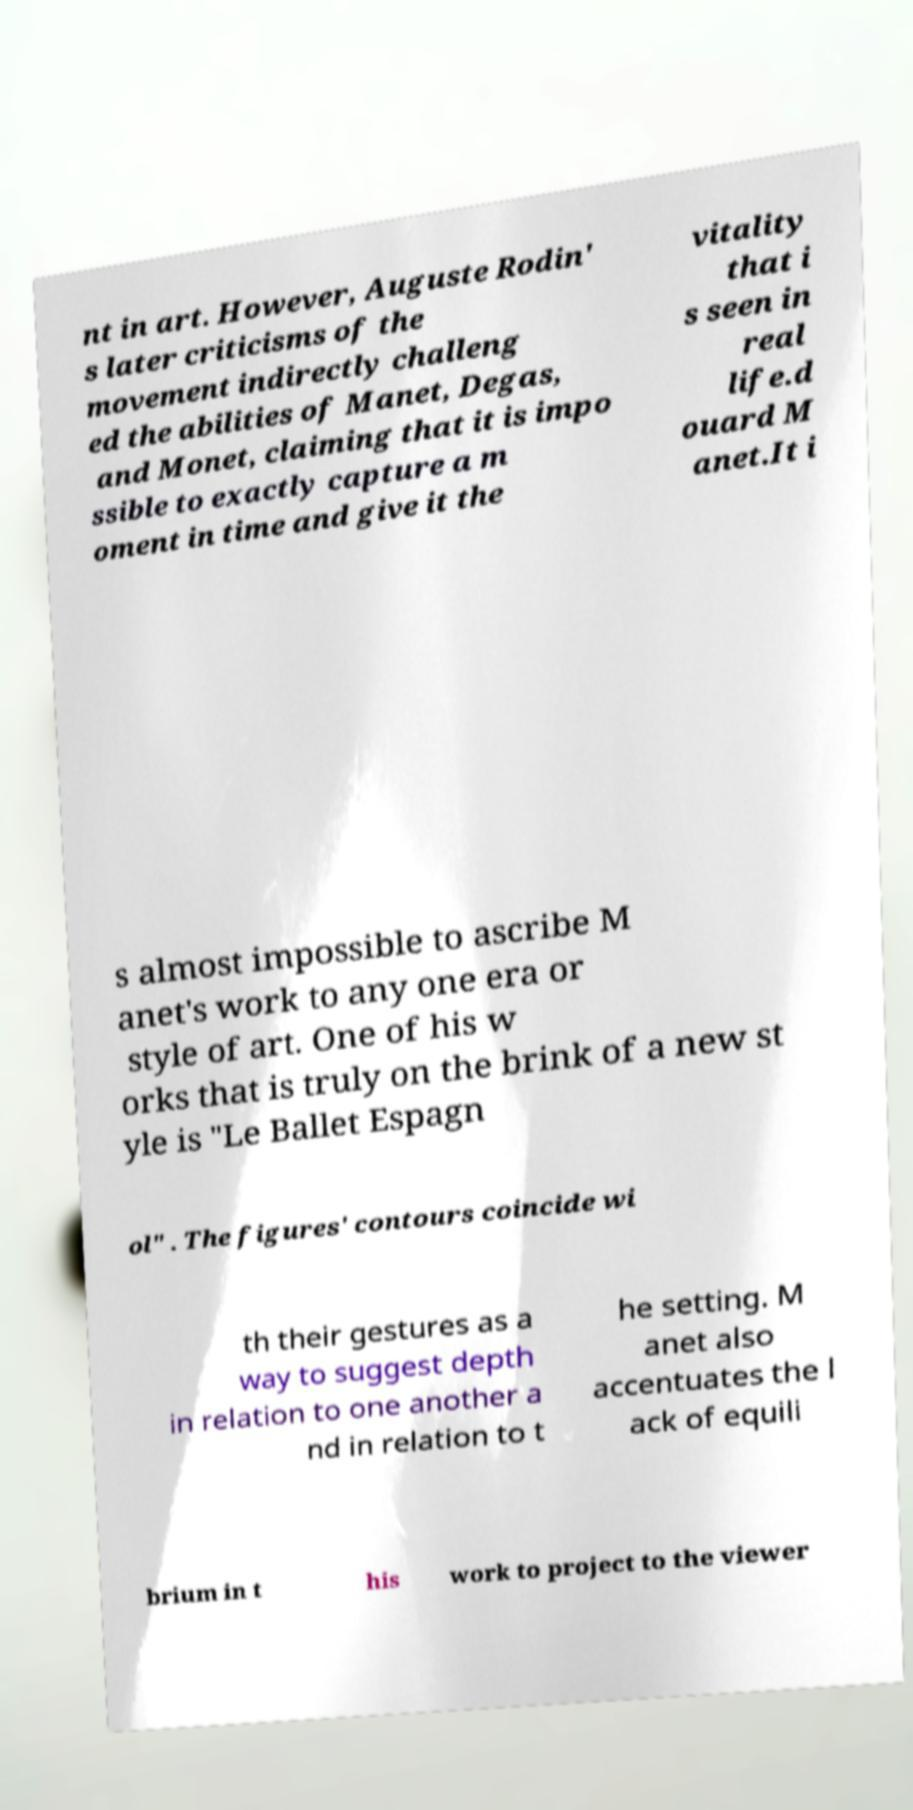I need the written content from this picture converted into text. Can you do that? nt in art. However, Auguste Rodin' s later criticisms of the movement indirectly challeng ed the abilities of Manet, Degas, and Monet, claiming that it is impo ssible to exactly capture a m oment in time and give it the vitality that i s seen in real life.d ouard M anet.It i s almost impossible to ascribe M anet's work to any one era or style of art. One of his w orks that is truly on the brink of a new st yle is "Le Ballet Espagn ol" . The figures' contours coincide wi th their gestures as a way to suggest depth in relation to one another a nd in relation to t he setting. M anet also accentuates the l ack of equili brium in t his work to project to the viewer 